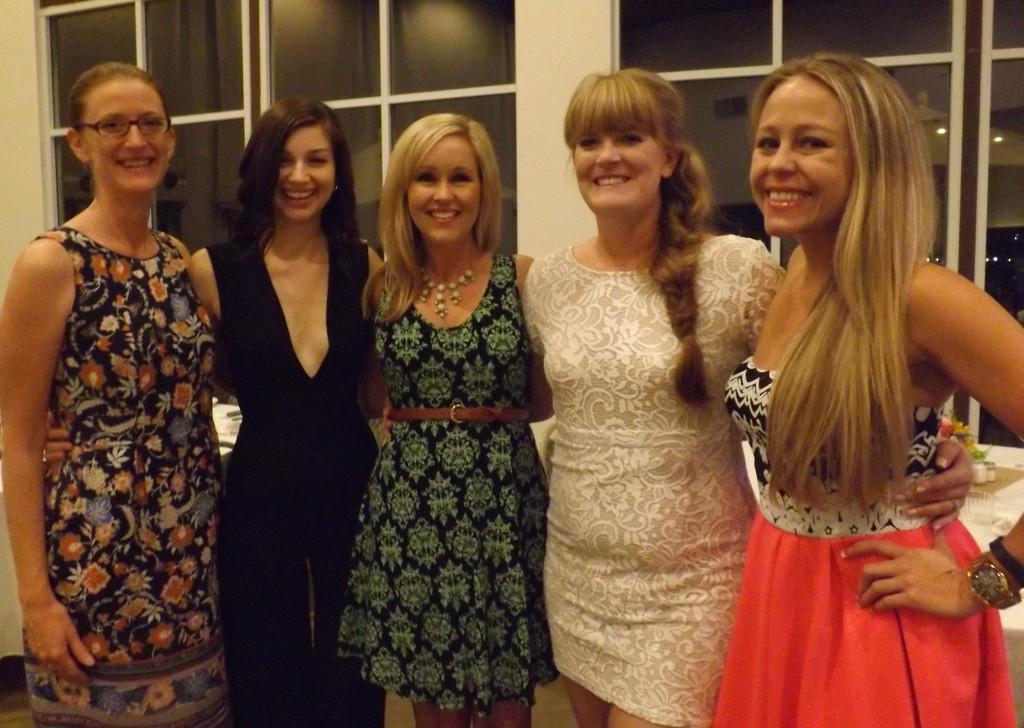Can you describe this image briefly? In this picture I can see a number of people with a smile and standing on the surface. I can see glass windows in the background. 